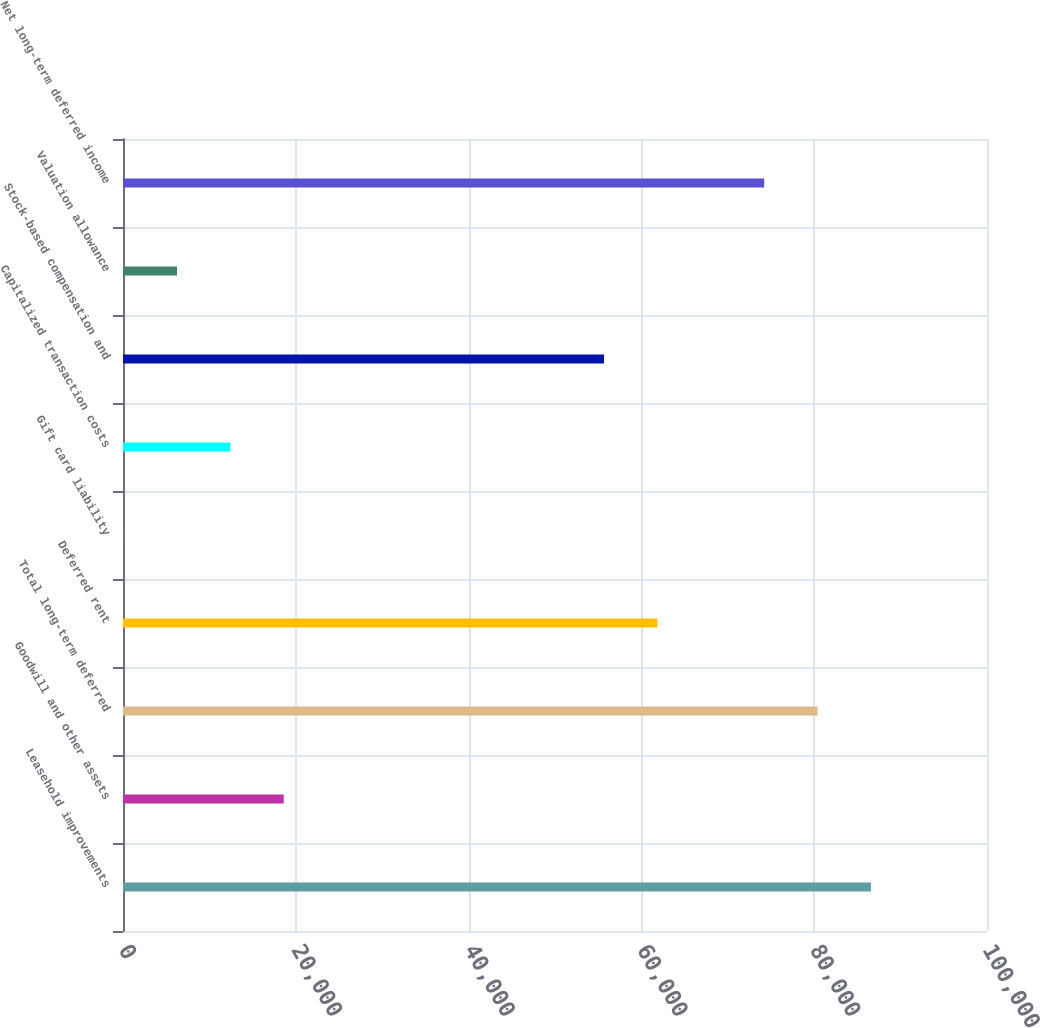<chart> <loc_0><loc_0><loc_500><loc_500><bar_chart><fcel>Leasehold improvements<fcel>Goodwill and other assets<fcel>Total long-term deferred<fcel>Deferred rent<fcel>Gift card liability<fcel>Capitalized transaction costs<fcel>Stock-based compensation and<fcel>Valuation allowance<fcel>Net long-term deferred income<nl><fcel>86570.4<fcel>18605.8<fcel>80391.8<fcel>61856<fcel>70<fcel>12427.2<fcel>55677.4<fcel>6248.6<fcel>74213.2<nl></chart> 